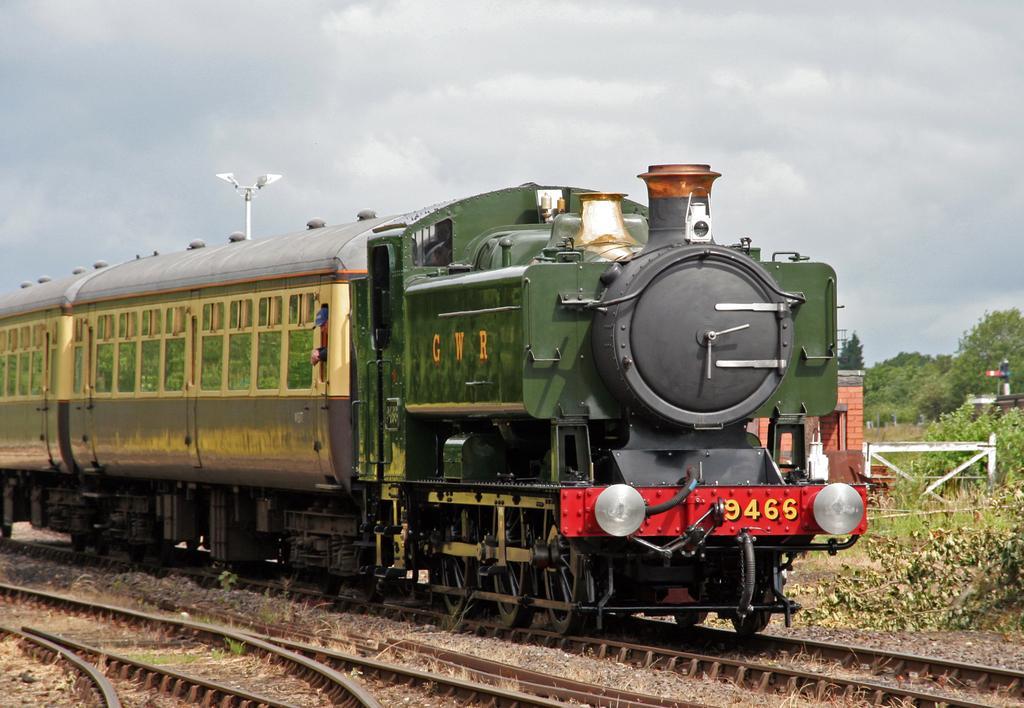How would you summarize this image in a sentence or two? In this image I can see train is on the track. Inside this train there is a person. In the background of the image there is a railing, trees, plants, cloudy sky. light pole and house. 